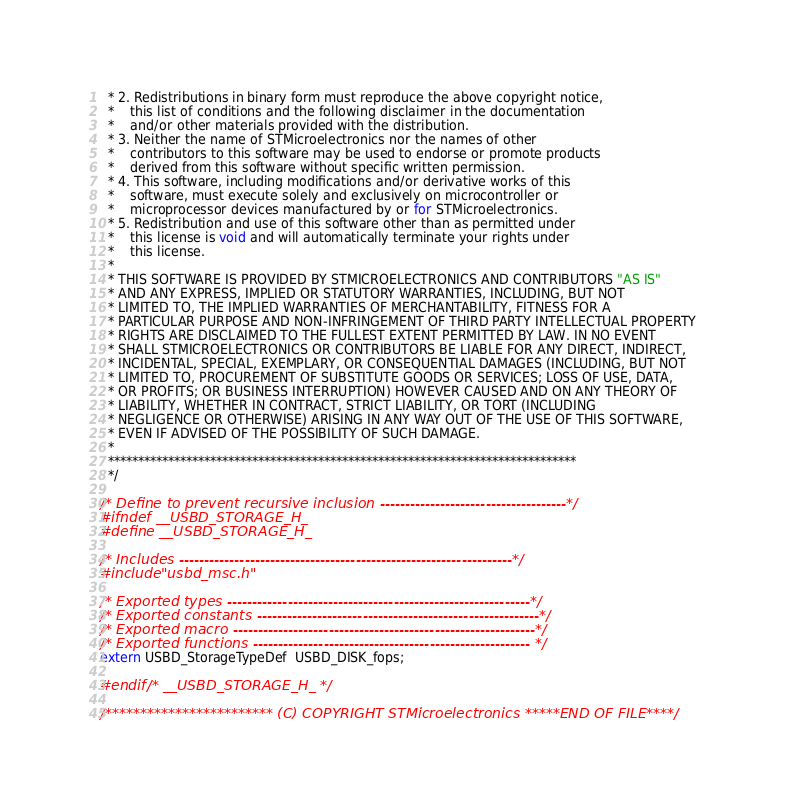Convert code to text. <code><loc_0><loc_0><loc_500><loc_500><_C_>  * 2. Redistributions in binary form must reproduce the above copyright notice,
  *    this list of conditions and the following disclaimer in the documentation
  *    and/or other materials provided with the distribution.
  * 3. Neither the name of STMicroelectronics nor the names of other 
  *    contributors to this software may be used to endorse or promote products 
  *    derived from this software without specific written permission.
  * 4. This software, including modifications and/or derivative works of this 
  *    software, must execute solely and exclusively on microcontroller or
  *    microprocessor devices manufactured by or for STMicroelectronics.
  * 5. Redistribution and use of this software other than as permitted under 
  *    this license is void and will automatically terminate your rights under 
  *    this license. 
  *
  * THIS SOFTWARE IS PROVIDED BY STMICROELECTRONICS AND CONTRIBUTORS "AS IS" 
  * AND ANY EXPRESS, IMPLIED OR STATUTORY WARRANTIES, INCLUDING, BUT NOT 
  * LIMITED TO, THE IMPLIED WARRANTIES OF MERCHANTABILITY, FITNESS FOR A 
  * PARTICULAR PURPOSE AND NON-INFRINGEMENT OF THIRD PARTY INTELLECTUAL PROPERTY
  * RIGHTS ARE DISCLAIMED TO THE FULLEST EXTENT PERMITTED BY LAW. IN NO EVENT 
  * SHALL STMICROELECTRONICS OR CONTRIBUTORS BE LIABLE FOR ANY DIRECT, INDIRECT,
  * INCIDENTAL, SPECIAL, EXEMPLARY, OR CONSEQUENTIAL DAMAGES (INCLUDING, BUT NOT
  * LIMITED TO, PROCUREMENT OF SUBSTITUTE GOODS OR SERVICES; LOSS OF USE, DATA, 
  * OR PROFITS; OR BUSINESS INTERRUPTION) HOWEVER CAUSED AND ON ANY THEORY OF 
  * LIABILITY, WHETHER IN CONTRACT, STRICT LIABILITY, OR TORT (INCLUDING 
  * NEGLIGENCE OR OTHERWISE) ARISING IN ANY WAY OUT OF THE USE OF THIS SOFTWARE,
  * EVEN IF ADVISED OF THE POSSIBILITY OF SUCH DAMAGE.
  *
  ******************************************************************************
  */
  
/* Define to prevent recursive inclusion -------------------------------------*/
#ifndef __USBD_STORAGE_H_
#define __USBD_STORAGE_H_

/* Includes ------------------------------------------------------------------*/
#include "usbd_msc.h"

/* Exported types ------------------------------------------------------------*/
/* Exported constants --------------------------------------------------------*/
/* Exported macro ------------------------------------------------------------*/
/* Exported functions ------------------------------------------------------- */
extern USBD_StorageTypeDef  USBD_DISK_fops;

#endif /* __USBD_STORAGE_H_ */
 
/************************ (C) COPYRIGHT STMicroelectronics *****END OF FILE****/
</code> 